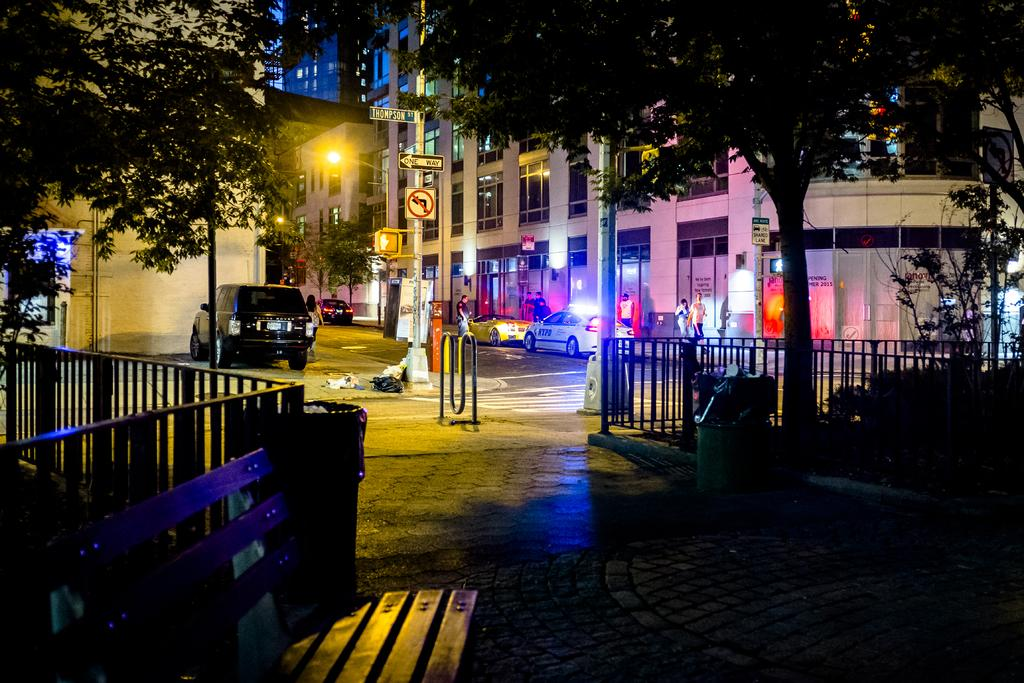What type of structures can be seen in the image? There are buildings in the image. What is illuminating the scene in the image? There are lights in the image. What are the poles used for in the image? The poles are likely used for supporting lights or other infrastructure. What type of transportation is present in the image? There are vehicles in the image. What type of vegetation can be seen in the image? There are trees in the image. What type of people can be seen in the image? There are people in the image. What type of barrier is present in the image? There is a fence in the image. What type of waste disposal container is present in the image? There is a dustbin in the image. What type of sand can be seen on the chessboard in the image? There is no chessboard or sand present in the image. What type of structure is the chess piece supporting in the image? There are no chess pieces or structures present in the image. 